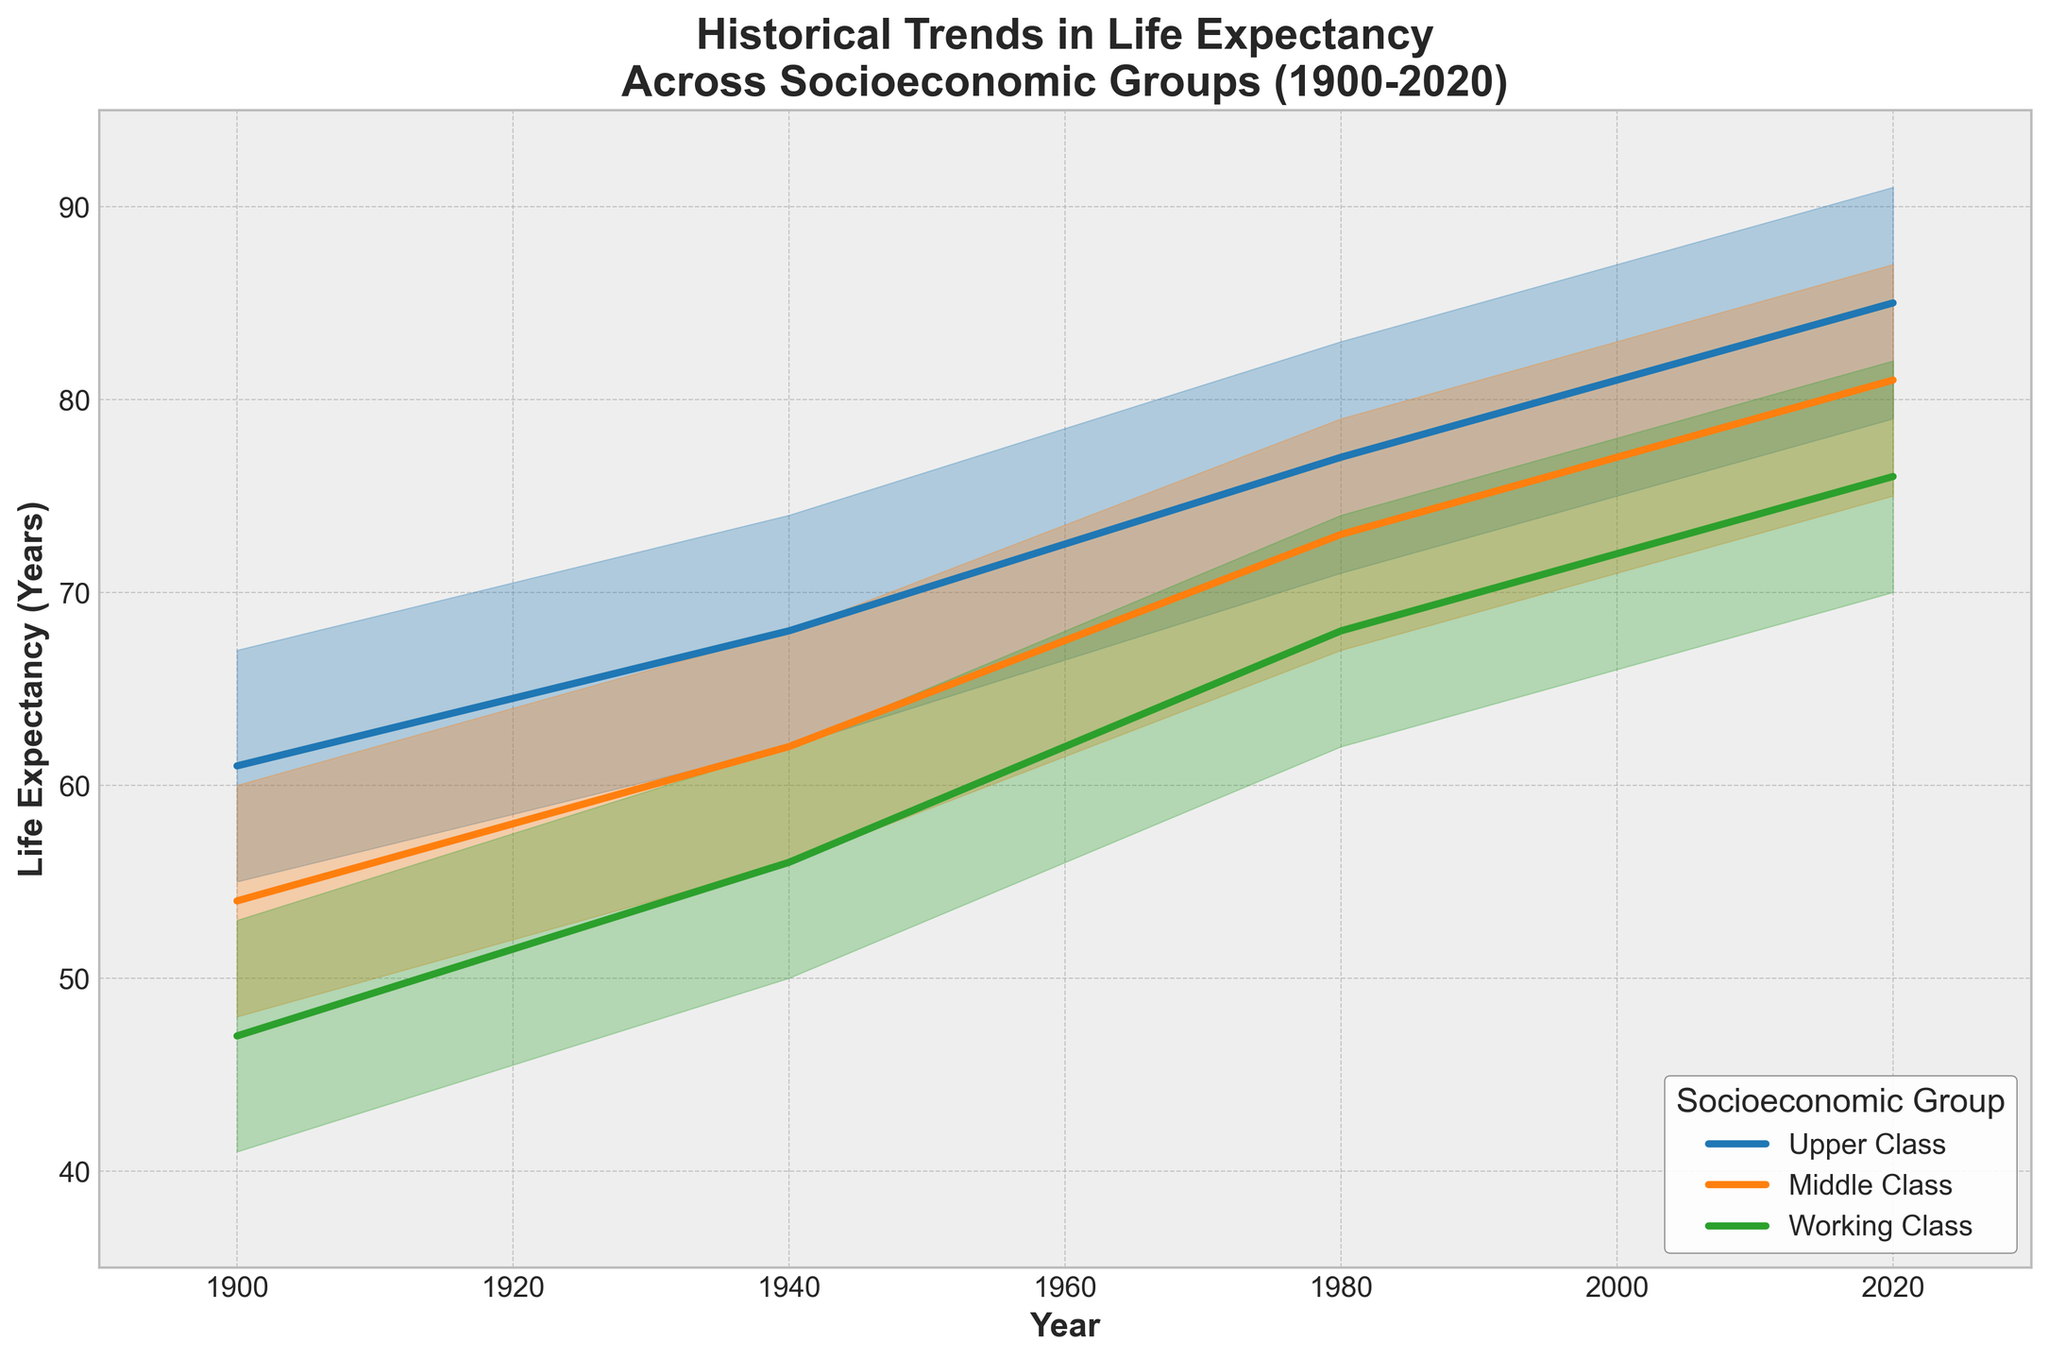What is the title of the figure? The title is located at the top of the figure and summarizes what the figure represents. In this case, it reads "Historical Trends in Life Expectancy Across Socioeconomic Groups (1900-2020)."
Answer: Historical Trends in Life Expectancy Across Socioeconomic Groups (1900-2020) What are the colors used to represent the different socioeconomic groups? The figure uses three distinct colors to differentiate between socioeconomic groups. The colors are blue, orange, and green.
Answer: Blue, orange, and green Which socioeconomic group had the highest life expectancy in 1900? The figure shows life expectancy bands for each group, and the Upper Class has the highest band in 1900.
Answer: Upper Class What is the range of life expectancy for the Middle Class in 2020? The range is determined by looking at the "Low" and "High" life expectancy values for the Middle Class in 2020. The values show a range from 75 to 87 years.
Answer: 75-87 years How much did the average life expectancy (Mid) for the Working Class increase from 1900 to 2020? The Mid value for the Working Class in 1900 is 47 years, and in 2020 it is 76 years. The difference is 76 - 47.
Answer: 29 years Which socioeconomic group shows the smallest increase in life expectancy from 1900 to 2020? By examining the bands for the years 1900 and 2020, the Working Class shows the smallest increase, from a Mid value of 47 to 76. This calculation must be performed for all groups to confirm.
Answer: Working Class What is the trend in life expectancy over time for all groups? The figure shows an increasing trend for all groups from 1900 to 2020. This is evident through the upward slope of the Mid lines for each group.
Answer: Increasing trend Compare the life expectancy range of the Upper Class in 1900 with the Middle Class in 1980. Which is higher? The Upper Class in 1900 has a range from 55 to 67 years, and the Middle Class in 1980 has a range from 67 to 79 years. The Middle Class in 1980 has a higher range.
Answer: Middle Class in 1980 In which decade(s) did the Upper Class have the steepest increase in life expectancy? The steepest increase is determined by the steepest slope in the Mid line for the Upper Class. Observing the line, the steepest increase appears in the decades from 1940 to 1980.
Answer: 1940 to 1980 What is the difference in life expectancy between the High and Low values for the Working Class in 2020? The High value for the Working Class in 2020 is 82 years and the Low value is 70 years. The difference is 82 - 70.
Answer: 12 years 